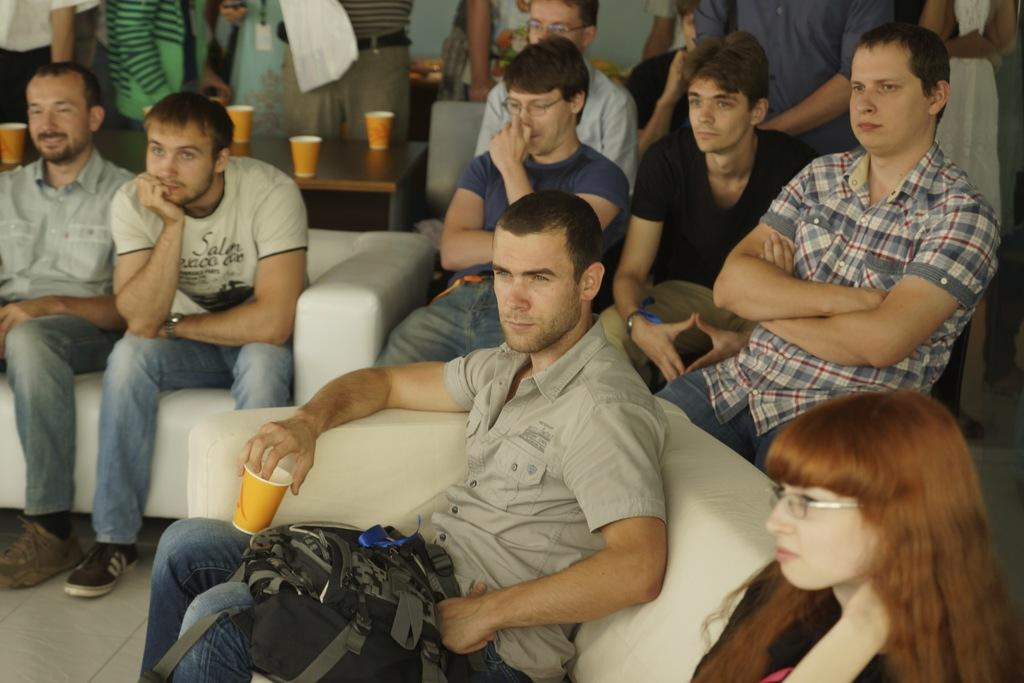What are the people in the image doing? The people in the image are sitting on sofas. What can be seen in the background of the image? There is a table in the background of the image. What is on the table in the image? There are cups on the table. Are there any other people visible in the image? Yes, there are people standing in the background of the image. How many times does the person on the left sneeze in the image? There is no indication of anyone sneezing in the image. What type of shelf is visible in the image? There is no shelf present in the image. 